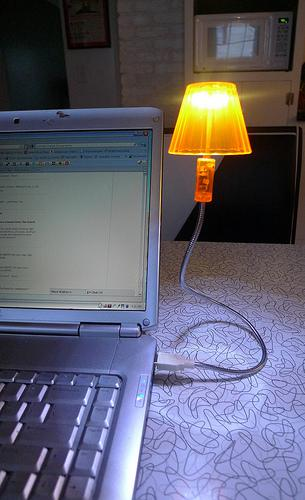Question: who put on the light?
Choices:
A. The computer user.
B. The man.
C. The woman.
D. The child.
Answer with the letter. Answer: A Question: where is the lamp?
Choices:
A. On the table.
B. Next to the computer.
C. On the dresser.
D. On the desk.
Answer with the letter. Answer: B Question: when is the lamp on?
Choices:
A. At dawn.
B. At dusk.
C. Now.
D. At night.
Answer with the letter. Answer: C Question: why is the lamp on?
Choices:
A. It is dark.
B. It is night.
C. They forgot to turn it off.
D. Light is needed.
Answer with the letter. Answer: D Question: what kind of computer is there?
Choices:
A. Laptop.
B. Desktop.
C. iPad.
D. Cell phone.
Answer with the letter. Answer: A 